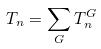Convert formula to latex. <formula><loc_0><loc_0><loc_500><loc_500>T _ { n } = \sum _ { G } T _ { n } ^ { G }</formula> 